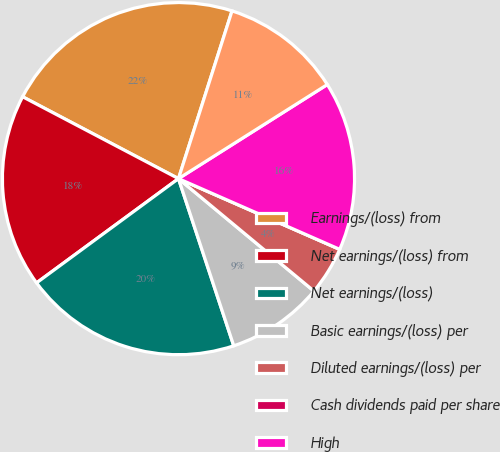<chart> <loc_0><loc_0><loc_500><loc_500><pie_chart><fcel>Earnings/(loss) from<fcel>Net earnings/(loss) from<fcel>Net earnings/(loss)<fcel>Basic earnings/(loss) per<fcel>Diluted earnings/(loss) per<fcel>Cash dividends paid per share<fcel>High<fcel>Low<nl><fcel>22.22%<fcel>17.78%<fcel>20.0%<fcel>8.89%<fcel>4.45%<fcel>0.0%<fcel>15.55%<fcel>11.11%<nl></chart> 